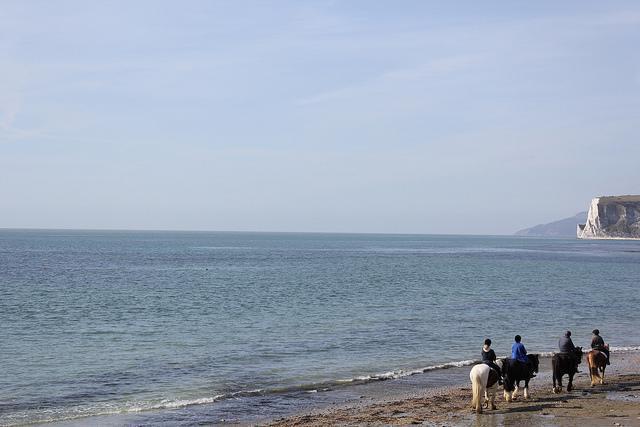How many horses are white?
Give a very brief answer. 1. How many people in picture?
Give a very brief answer. 4. 